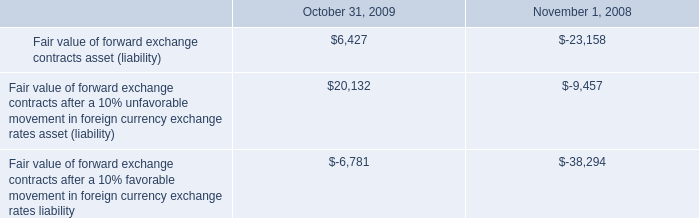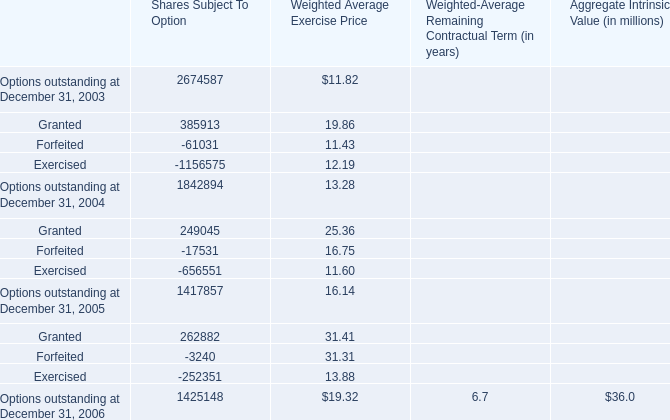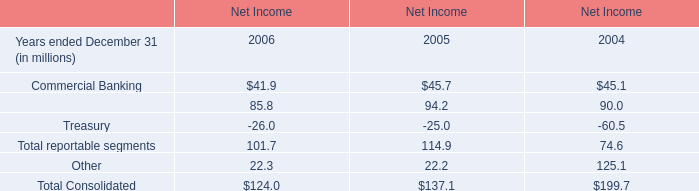What is the sum of Granted, Forfeited and Exercised for Shares Subject To Option in 2003 ? 
Computations: ((385913 - 61031) - 1156575)
Answer: -831693.0. 